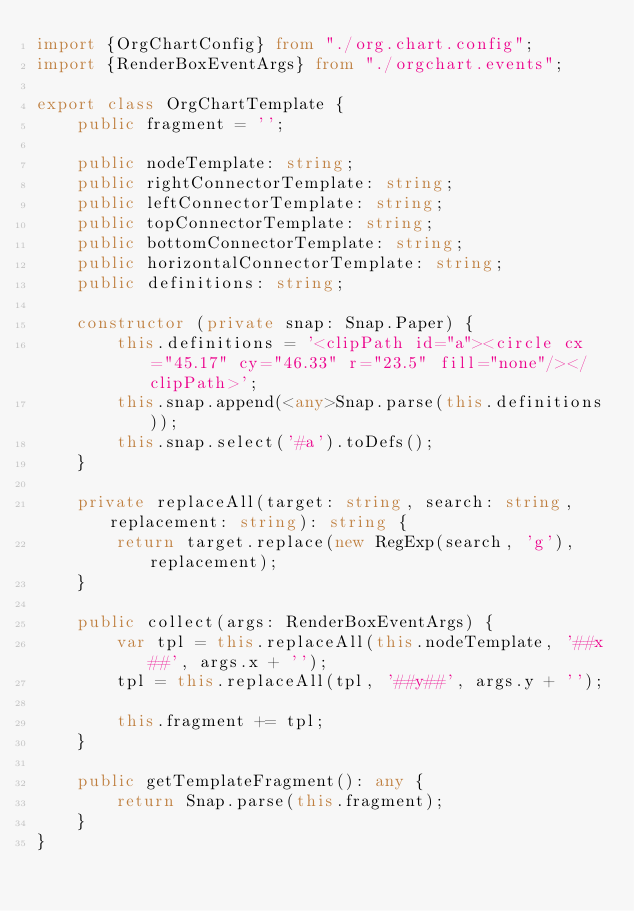Convert code to text. <code><loc_0><loc_0><loc_500><loc_500><_TypeScript_>import {OrgChartConfig} from "./org.chart.config";
import {RenderBoxEventArgs} from "./orgchart.events";

export class OrgChartTemplate {
	public fragment = '';

	public nodeTemplate: string;
	public rightConnectorTemplate: string;
	public leftConnectorTemplate: string;
	public topConnectorTemplate: string;
	public bottomConnectorTemplate: string;
	public horizontalConnectorTemplate: string;
	public definitions: string;

	constructor (private snap: Snap.Paper) {
		this.definitions = '<clipPath id="a"><circle cx="45.17" cy="46.33" r="23.5" fill="none"/></clipPath>';
		this.snap.append(<any>Snap.parse(this.definitions));
		this.snap.select('#a').toDefs();
	}

	private replaceAll(target: string, search: string, replacement: string): string {
		return target.replace(new RegExp(search, 'g'), replacement);
	}

	public collect(args: RenderBoxEventArgs) {
		var tpl = this.replaceAll(this.nodeTemplate, '##x##', args.x + '');
		tpl = this.replaceAll(tpl, '##y##', args.y + '');

		this.fragment += tpl;
	}

	public getTemplateFragment(): any {
		return Snap.parse(this.fragment);
	}
}
</code> 